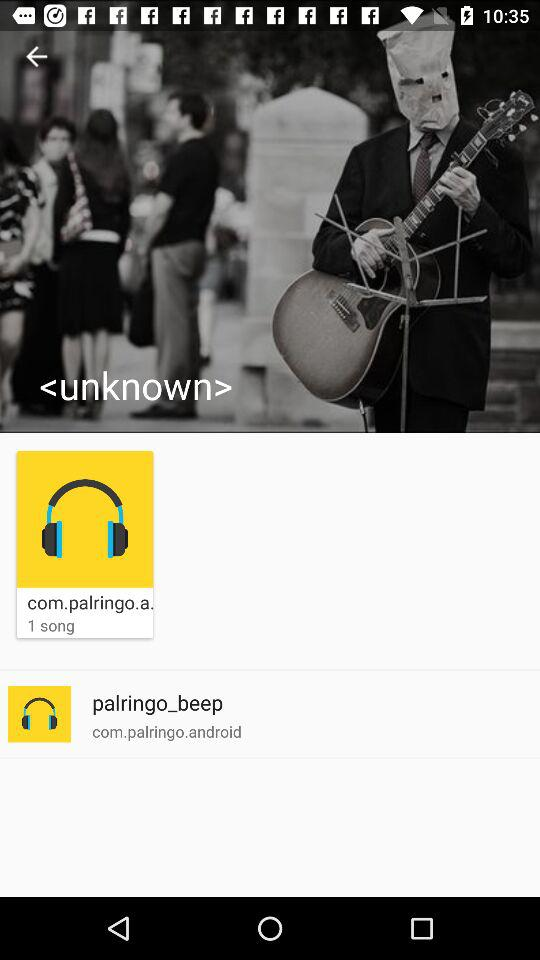How many songs are there? There is 1 song. 